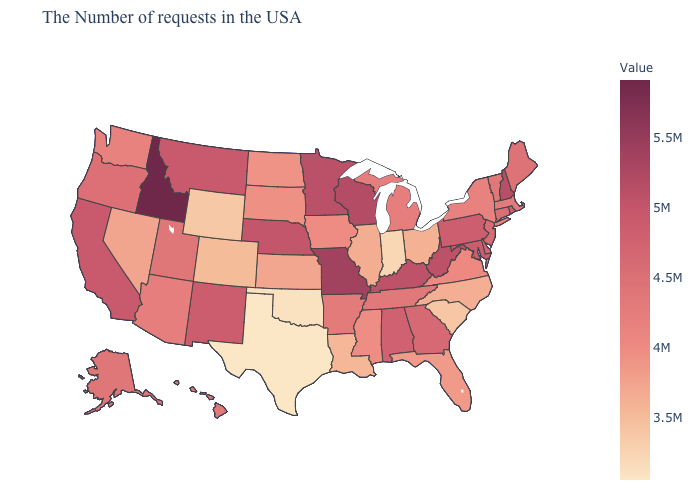Does New Jersey have a lower value than Idaho?
Quick response, please. Yes. Which states have the lowest value in the USA?
Concise answer only. Texas. Among the states that border Rhode Island , which have the highest value?
Be succinct. Connecticut. Among the states that border Iowa , does Illinois have the highest value?
Concise answer only. No. Among the states that border Iowa , does Wisconsin have the highest value?
Be succinct. No. 